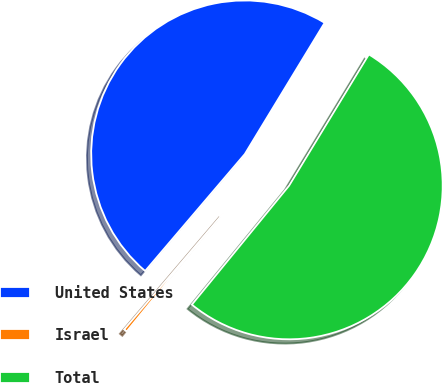<chart> <loc_0><loc_0><loc_500><loc_500><pie_chart><fcel>United States<fcel>Israel<fcel>Total<nl><fcel>47.46%<fcel>0.33%<fcel>52.21%<nl></chart> 